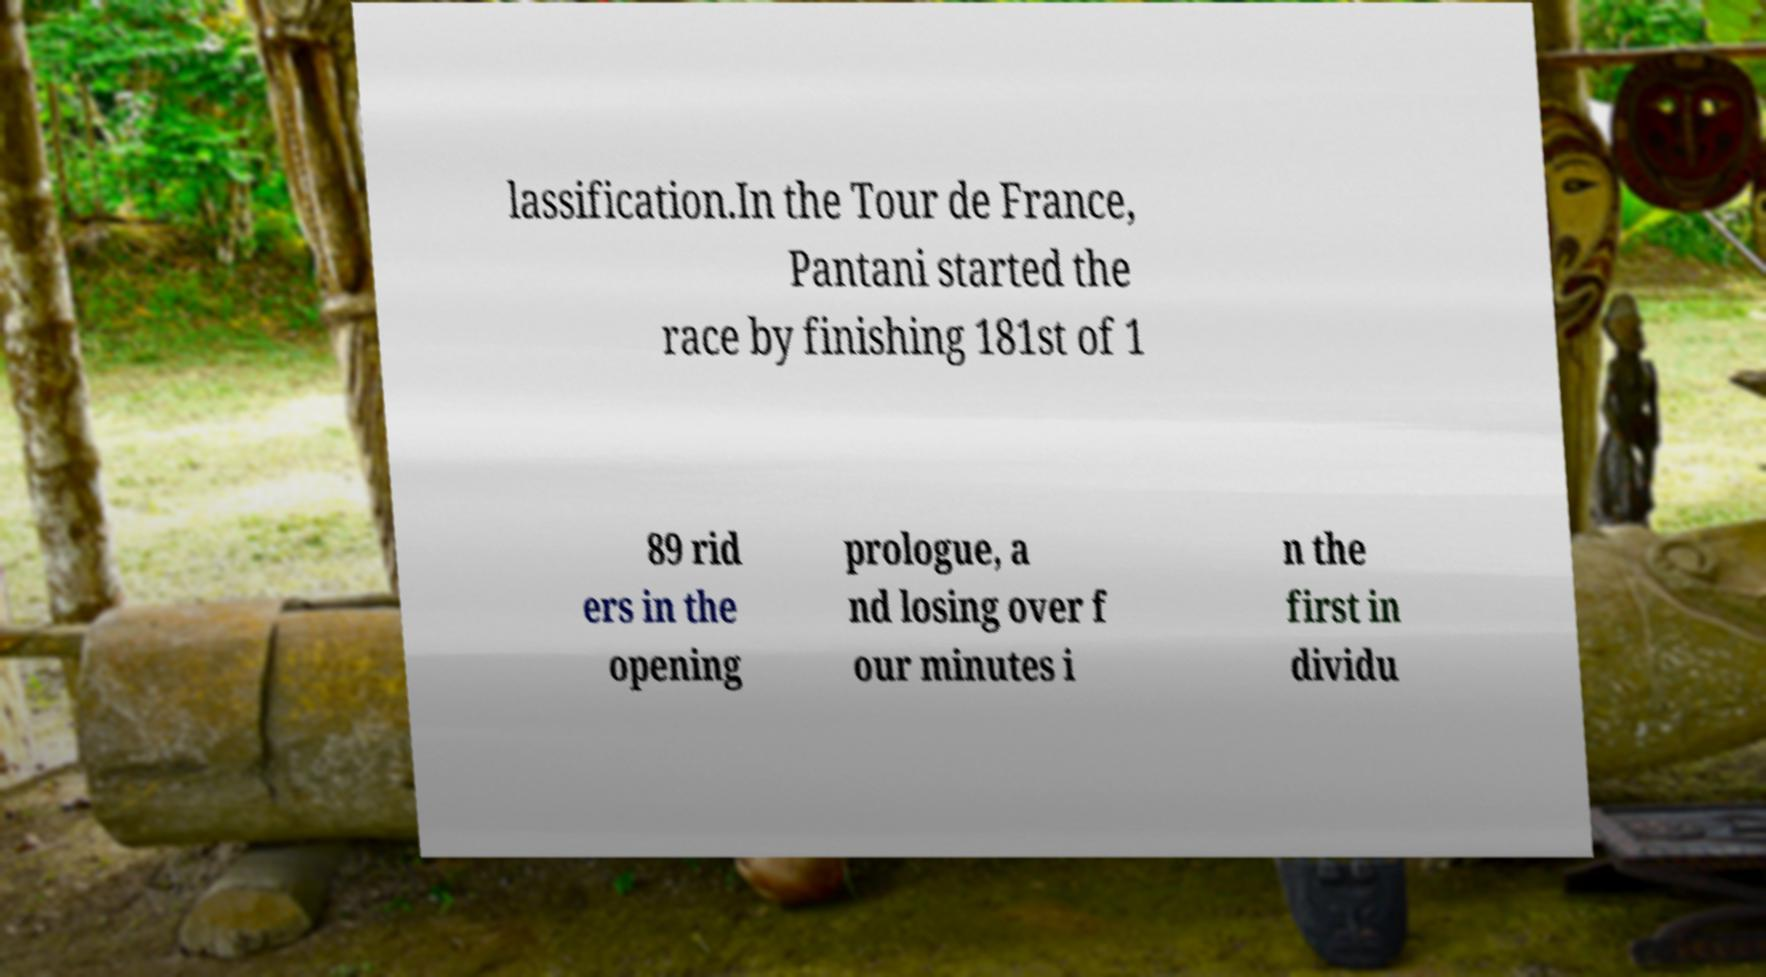For documentation purposes, I need the text within this image transcribed. Could you provide that? lassification.In the Tour de France, Pantani started the race by finishing 181st of 1 89 rid ers in the opening prologue, a nd losing over f our minutes i n the first in dividu 